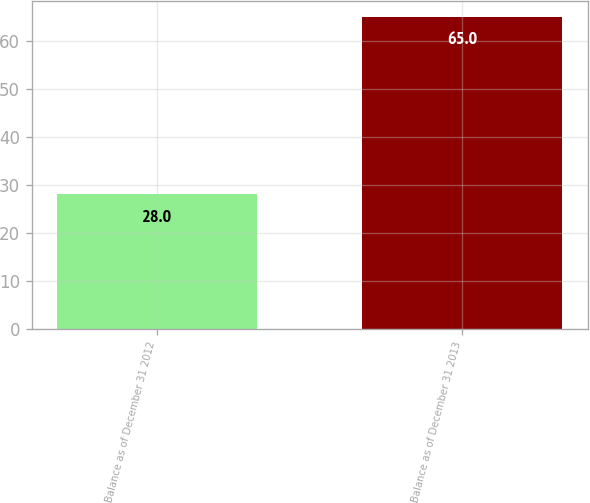<chart> <loc_0><loc_0><loc_500><loc_500><bar_chart><fcel>Balance as of December 31 2012<fcel>Balance as of December 31 2013<nl><fcel>28<fcel>65<nl></chart> 